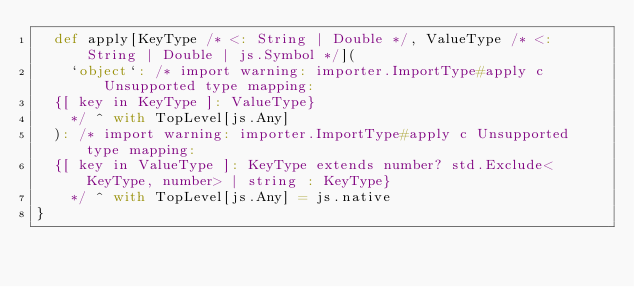<code> <loc_0><loc_0><loc_500><loc_500><_Scala_>  def apply[KeyType /* <: String | Double */, ValueType /* <: String | Double | js.Symbol */](
    `object`: /* import warning: importer.ImportType#apply c Unsupported type mapping: 
  {[ key in KeyType ]: ValueType}
    */ ^ with TopLevel[js.Any]
  ): /* import warning: importer.ImportType#apply c Unsupported type mapping: 
  {[ key in ValueType ]: KeyType extends number? std.Exclude<KeyType, number> | string : KeyType}
    */ ^ with TopLevel[js.Any] = js.native
}
</code> 